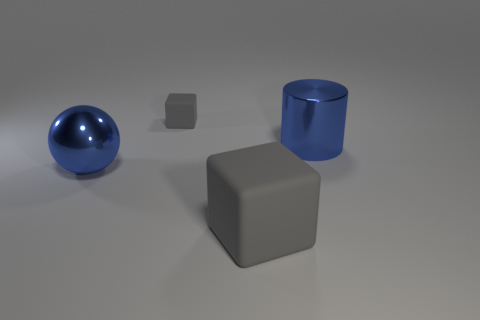How big is the matte block in front of the cube behind the large blue cylinder in front of the tiny gray rubber thing? The matte block in question appears to be of medium size relative to the objects around it. It's larger than the small cube and the tiny gray object, yet smaller than the blue cylinder behind it. 